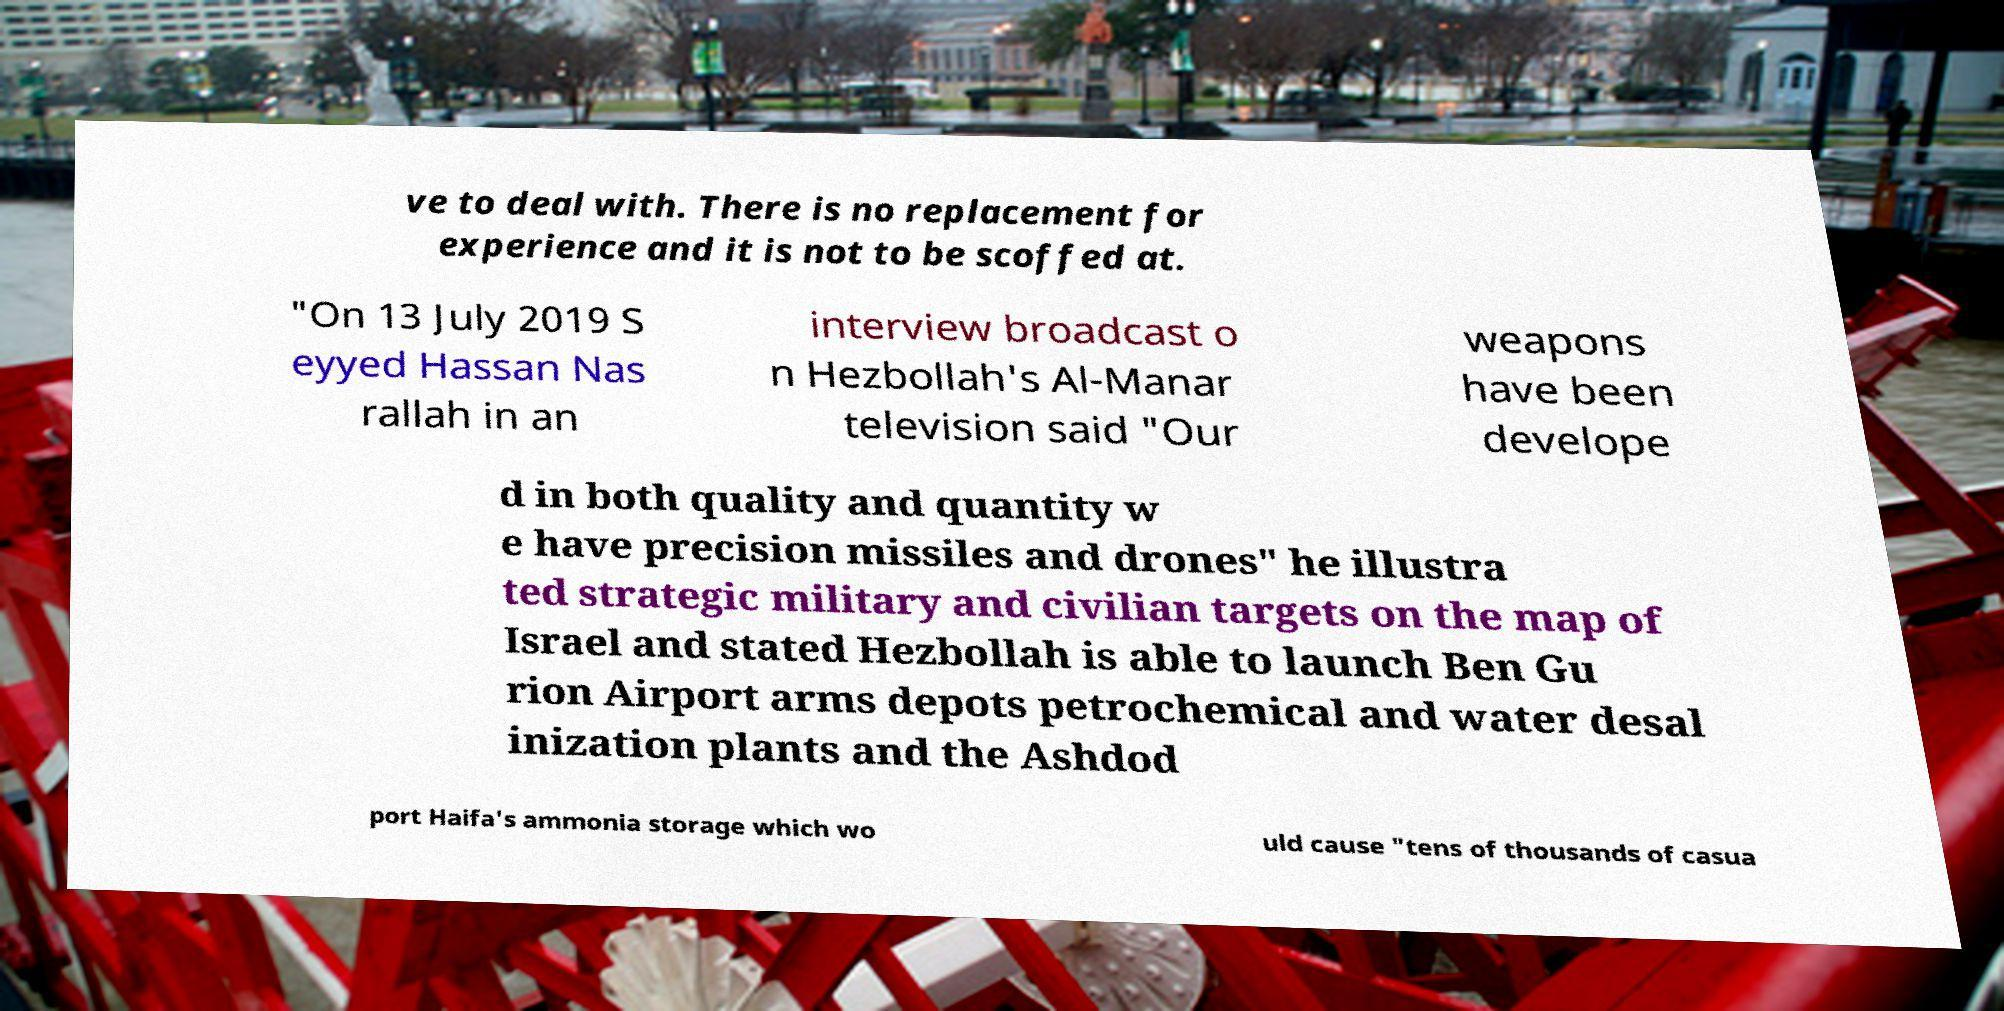Could you assist in decoding the text presented in this image and type it out clearly? ve to deal with. There is no replacement for experience and it is not to be scoffed at. "On 13 July 2019 S eyyed Hassan Nas rallah in an interview broadcast o n Hezbollah's Al-Manar television said "Our weapons have been develope d in both quality and quantity w e have precision missiles and drones" he illustra ted strategic military and civilian targets on the map of Israel and stated Hezbollah is able to launch Ben Gu rion Airport arms depots petrochemical and water desal inization plants and the Ashdod port Haifa's ammonia storage which wo uld cause "tens of thousands of casua 